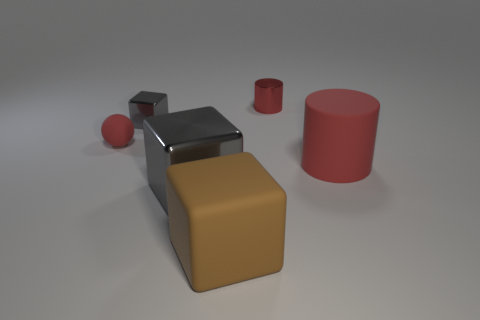Subtract all gray shiny blocks. How many blocks are left? 1 Subtract all gray cylinders. How many gray cubes are left? 2 Add 1 large blue metallic cylinders. How many objects exist? 7 Subtract 1 blocks. How many blocks are left? 2 Subtract all spheres. How many objects are left? 5 Subtract all cyan blocks. Subtract all purple balls. How many blocks are left? 3 Subtract all small blue shiny blocks. Subtract all red matte things. How many objects are left? 4 Add 6 red cylinders. How many red cylinders are left? 8 Add 6 tiny metallic things. How many tiny metallic things exist? 8 Subtract 0 green balls. How many objects are left? 6 